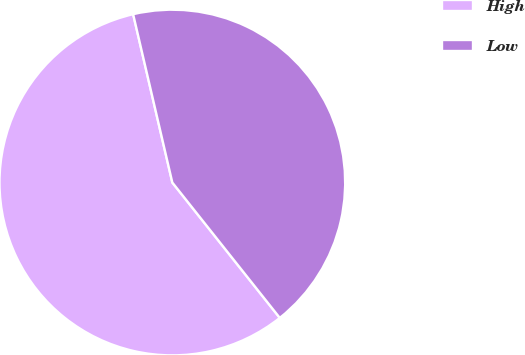Convert chart to OTSL. <chart><loc_0><loc_0><loc_500><loc_500><pie_chart><fcel>High<fcel>Low<nl><fcel>57.04%<fcel>42.96%<nl></chart> 